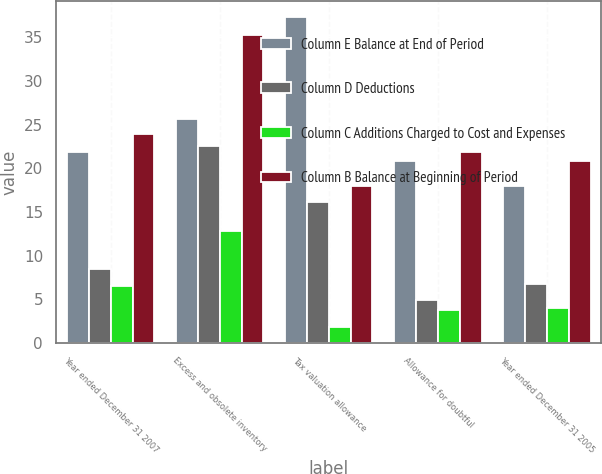Convert chart. <chart><loc_0><loc_0><loc_500><loc_500><stacked_bar_chart><ecel><fcel>Year ended December 31 2007<fcel>Excess and obsolete inventory<fcel>Tax valuation allowance<fcel>Allowance for doubtful<fcel>Year ended December 31 2005<nl><fcel>Column E Balance at End of Period<fcel>21.9<fcel>25.6<fcel>37.3<fcel>20.8<fcel>18<nl><fcel>Column D Deductions<fcel>8.5<fcel>22.5<fcel>16.1<fcel>4.9<fcel>6.8<nl><fcel>Column C Additions Charged to Cost and Expenses<fcel>6.52<fcel>12.8<fcel>1.83<fcel>3.82<fcel>4.02<nl><fcel>Column B Balance at Beginning of Period<fcel>23.9<fcel>35.3<fcel>18<fcel>21.9<fcel>20.8<nl></chart> 